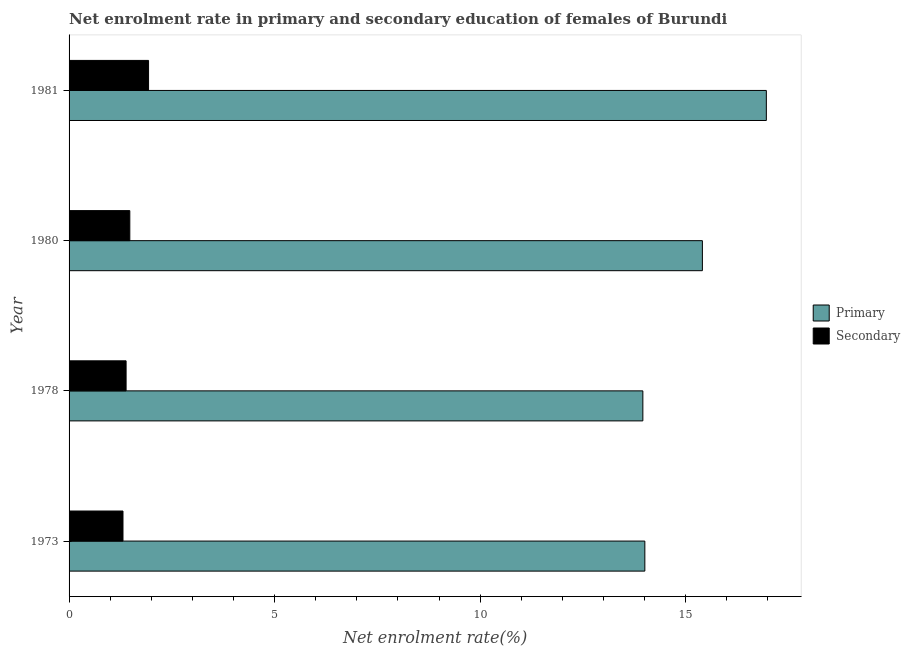How many different coloured bars are there?
Make the answer very short. 2. Are the number of bars on each tick of the Y-axis equal?
Your answer should be very brief. Yes. How many bars are there on the 3rd tick from the top?
Your answer should be compact. 2. In how many cases, is the number of bars for a given year not equal to the number of legend labels?
Provide a succinct answer. 0. What is the enrollment rate in primary education in 1980?
Provide a short and direct response. 15.41. Across all years, what is the maximum enrollment rate in secondary education?
Ensure brevity in your answer.  1.93. Across all years, what is the minimum enrollment rate in secondary education?
Ensure brevity in your answer.  1.31. What is the total enrollment rate in secondary education in the graph?
Make the answer very short. 6.11. What is the difference between the enrollment rate in secondary education in 1973 and that in 1978?
Provide a short and direct response. -0.08. What is the difference between the enrollment rate in primary education in 1978 and the enrollment rate in secondary education in 1981?
Provide a succinct answer. 12.03. What is the average enrollment rate in primary education per year?
Your answer should be very brief. 15.09. In the year 1980, what is the difference between the enrollment rate in primary education and enrollment rate in secondary education?
Your answer should be compact. 13.93. What is the ratio of the enrollment rate in primary education in 1980 to that in 1981?
Provide a succinct answer. 0.91. Is the enrollment rate in primary education in 1978 less than that in 1980?
Give a very brief answer. Yes. Is the difference between the enrollment rate in primary education in 1980 and 1981 greater than the difference between the enrollment rate in secondary education in 1980 and 1981?
Your response must be concise. No. What is the difference between the highest and the second highest enrollment rate in secondary education?
Keep it short and to the point. 0.46. What is the difference between the highest and the lowest enrollment rate in primary education?
Ensure brevity in your answer.  3. Is the sum of the enrollment rate in primary education in 1978 and 1980 greater than the maximum enrollment rate in secondary education across all years?
Make the answer very short. Yes. What does the 2nd bar from the top in 1980 represents?
Keep it short and to the point. Primary. What does the 2nd bar from the bottom in 1980 represents?
Keep it short and to the point. Secondary. How many bars are there?
Offer a very short reply. 8. How are the legend labels stacked?
Keep it short and to the point. Vertical. What is the title of the graph?
Ensure brevity in your answer.  Net enrolment rate in primary and secondary education of females of Burundi. What is the label or title of the X-axis?
Make the answer very short. Net enrolment rate(%). What is the label or title of the Y-axis?
Give a very brief answer. Year. What is the Net enrolment rate(%) in Primary in 1973?
Your answer should be very brief. 14.01. What is the Net enrolment rate(%) of Secondary in 1973?
Provide a succinct answer. 1.31. What is the Net enrolment rate(%) of Primary in 1978?
Ensure brevity in your answer.  13.96. What is the Net enrolment rate(%) of Secondary in 1978?
Your answer should be compact. 1.39. What is the Net enrolment rate(%) of Primary in 1980?
Ensure brevity in your answer.  15.41. What is the Net enrolment rate(%) in Secondary in 1980?
Keep it short and to the point. 1.48. What is the Net enrolment rate(%) in Primary in 1981?
Provide a short and direct response. 16.96. What is the Net enrolment rate(%) in Secondary in 1981?
Offer a very short reply. 1.93. Across all years, what is the maximum Net enrolment rate(%) of Primary?
Ensure brevity in your answer.  16.96. Across all years, what is the maximum Net enrolment rate(%) in Secondary?
Provide a succinct answer. 1.93. Across all years, what is the minimum Net enrolment rate(%) of Primary?
Give a very brief answer. 13.96. Across all years, what is the minimum Net enrolment rate(%) of Secondary?
Your response must be concise. 1.31. What is the total Net enrolment rate(%) in Primary in the graph?
Keep it short and to the point. 60.34. What is the total Net enrolment rate(%) in Secondary in the graph?
Provide a succinct answer. 6.11. What is the difference between the Net enrolment rate(%) in Primary in 1973 and that in 1978?
Offer a very short reply. 0.05. What is the difference between the Net enrolment rate(%) in Secondary in 1973 and that in 1978?
Your answer should be very brief. -0.08. What is the difference between the Net enrolment rate(%) in Primary in 1973 and that in 1980?
Keep it short and to the point. -1.4. What is the difference between the Net enrolment rate(%) in Secondary in 1973 and that in 1980?
Your answer should be very brief. -0.17. What is the difference between the Net enrolment rate(%) of Primary in 1973 and that in 1981?
Offer a terse response. -2.96. What is the difference between the Net enrolment rate(%) of Secondary in 1973 and that in 1981?
Ensure brevity in your answer.  -0.62. What is the difference between the Net enrolment rate(%) in Primary in 1978 and that in 1980?
Ensure brevity in your answer.  -1.45. What is the difference between the Net enrolment rate(%) in Secondary in 1978 and that in 1980?
Provide a succinct answer. -0.09. What is the difference between the Net enrolment rate(%) of Primary in 1978 and that in 1981?
Make the answer very short. -3. What is the difference between the Net enrolment rate(%) in Secondary in 1978 and that in 1981?
Give a very brief answer. -0.55. What is the difference between the Net enrolment rate(%) in Primary in 1980 and that in 1981?
Provide a succinct answer. -1.56. What is the difference between the Net enrolment rate(%) of Secondary in 1980 and that in 1981?
Your answer should be compact. -0.46. What is the difference between the Net enrolment rate(%) of Primary in 1973 and the Net enrolment rate(%) of Secondary in 1978?
Give a very brief answer. 12.62. What is the difference between the Net enrolment rate(%) in Primary in 1973 and the Net enrolment rate(%) in Secondary in 1980?
Your answer should be compact. 12.53. What is the difference between the Net enrolment rate(%) in Primary in 1973 and the Net enrolment rate(%) in Secondary in 1981?
Your answer should be very brief. 12.07. What is the difference between the Net enrolment rate(%) in Primary in 1978 and the Net enrolment rate(%) in Secondary in 1980?
Provide a succinct answer. 12.48. What is the difference between the Net enrolment rate(%) of Primary in 1978 and the Net enrolment rate(%) of Secondary in 1981?
Your response must be concise. 12.03. What is the difference between the Net enrolment rate(%) of Primary in 1980 and the Net enrolment rate(%) of Secondary in 1981?
Your response must be concise. 13.47. What is the average Net enrolment rate(%) of Primary per year?
Your answer should be compact. 15.08. What is the average Net enrolment rate(%) of Secondary per year?
Your answer should be compact. 1.53. In the year 1973, what is the difference between the Net enrolment rate(%) in Primary and Net enrolment rate(%) in Secondary?
Your answer should be compact. 12.7. In the year 1978, what is the difference between the Net enrolment rate(%) of Primary and Net enrolment rate(%) of Secondary?
Give a very brief answer. 12.57. In the year 1980, what is the difference between the Net enrolment rate(%) in Primary and Net enrolment rate(%) in Secondary?
Offer a very short reply. 13.93. In the year 1981, what is the difference between the Net enrolment rate(%) in Primary and Net enrolment rate(%) in Secondary?
Offer a very short reply. 15.03. What is the ratio of the Net enrolment rate(%) in Secondary in 1973 to that in 1978?
Keep it short and to the point. 0.95. What is the ratio of the Net enrolment rate(%) in Primary in 1973 to that in 1980?
Give a very brief answer. 0.91. What is the ratio of the Net enrolment rate(%) of Secondary in 1973 to that in 1980?
Provide a succinct answer. 0.89. What is the ratio of the Net enrolment rate(%) in Primary in 1973 to that in 1981?
Offer a terse response. 0.83. What is the ratio of the Net enrolment rate(%) in Secondary in 1973 to that in 1981?
Your answer should be compact. 0.68. What is the ratio of the Net enrolment rate(%) of Primary in 1978 to that in 1980?
Your response must be concise. 0.91. What is the ratio of the Net enrolment rate(%) in Secondary in 1978 to that in 1980?
Give a very brief answer. 0.94. What is the ratio of the Net enrolment rate(%) of Primary in 1978 to that in 1981?
Your response must be concise. 0.82. What is the ratio of the Net enrolment rate(%) of Secondary in 1978 to that in 1981?
Offer a terse response. 0.72. What is the ratio of the Net enrolment rate(%) in Primary in 1980 to that in 1981?
Make the answer very short. 0.91. What is the ratio of the Net enrolment rate(%) of Secondary in 1980 to that in 1981?
Keep it short and to the point. 0.76. What is the difference between the highest and the second highest Net enrolment rate(%) in Primary?
Provide a short and direct response. 1.56. What is the difference between the highest and the second highest Net enrolment rate(%) in Secondary?
Ensure brevity in your answer.  0.46. What is the difference between the highest and the lowest Net enrolment rate(%) in Primary?
Your answer should be compact. 3. What is the difference between the highest and the lowest Net enrolment rate(%) of Secondary?
Your answer should be very brief. 0.62. 